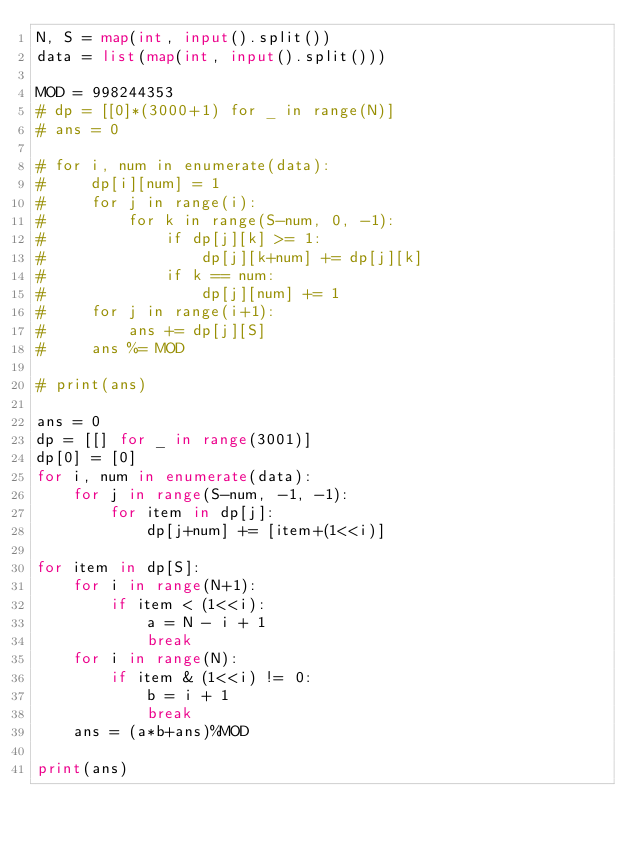<code> <loc_0><loc_0><loc_500><loc_500><_Python_>N, S = map(int, input().split())
data = list(map(int, input().split()))

MOD = 998244353
# dp = [[0]*(3000+1) for _ in range(N)]
# ans = 0

# for i, num in enumerate(data):
#     dp[i][num] = 1
#     for j in range(i):
#         for k in range(S-num, 0, -1):
#             if dp[j][k] >= 1:
#                 dp[j][k+num] += dp[j][k]
#             if k == num:
#                 dp[j][num] += 1
#     for j in range(i+1):
#         ans += dp[j][S]
#     ans %= MOD

# print(ans)

ans = 0
dp = [[] for _ in range(3001)]
dp[0] = [0]
for i, num in enumerate(data):
    for j in range(S-num, -1, -1):
        for item in dp[j]:
            dp[j+num] += [item+(1<<i)]

for item in dp[S]:
    for i in range(N+1):
        if item < (1<<i):
            a = N - i + 1
            break
    for i in range(N):
        if item & (1<<i) != 0:
            b = i + 1
            break
    ans = (a*b+ans)%MOD

print(ans)
</code> 